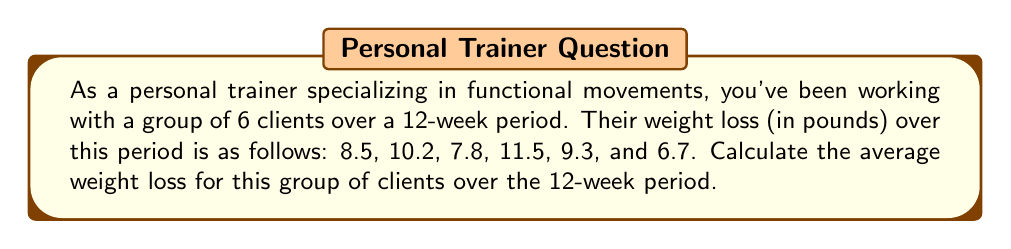Provide a solution to this math problem. To calculate the average weight loss, we need to follow these steps:

1. Sum up all the weight loss values:
   $$ \text{Total weight loss} = 8.5 + 10.2 + 7.8 + 11.5 + 9.3 + 6.7 $$
   $$ \text{Total weight loss} = 54 \text{ pounds} $$

2. Count the number of clients:
   $$ \text{Number of clients} = 6 $$

3. Use the formula for average (mean):
   $$ \text{Average} = \frac{\text{Sum of all values}}{\text{Number of values}} $$

4. Plug in the values:
   $$ \text{Average weight loss} = \frac{54}{6} = 9 \text{ pounds} $$

Therefore, the average weight loss for the group of clients over the 12-week period is 9 pounds.
Answer: $9 \text{ pounds}$ 